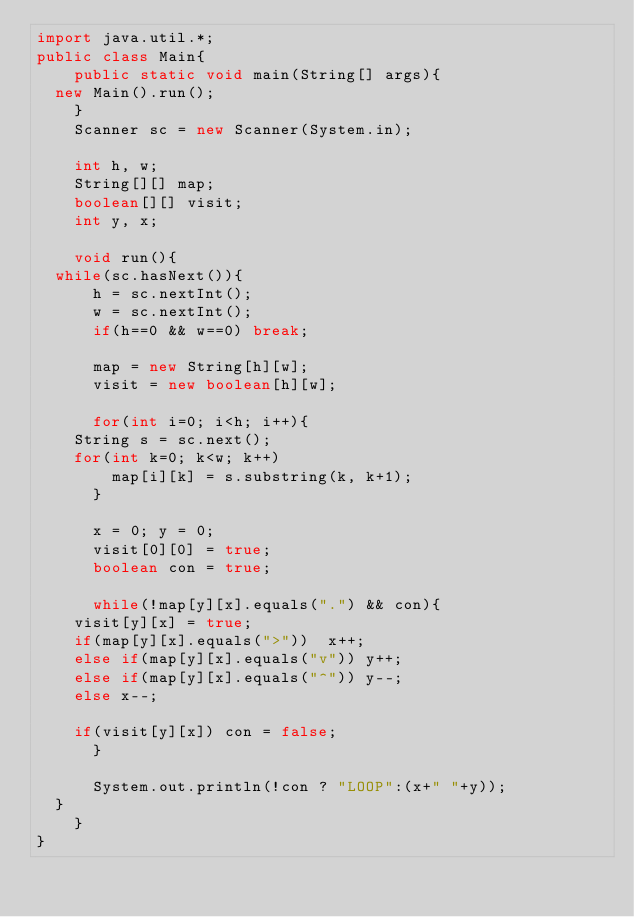Convert code to text. <code><loc_0><loc_0><loc_500><loc_500><_Java_>import java.util.*;
public class Main{
    public static void main(String[] args){
	new Main().run();
    }
    Scanner sc = new Scanner(System.in);

    int h, w;
    String[][] map;
    boolean[][] visit;
    int y, x;

    void run(){
	while(sc.hasNext()){
	    h = sc.nextInt();
	    w = sc.nextInt();
	    if(h==0 && w==0) break;

	    map = new String[h][w];
	    visit = new boolean[h][w];

	    for(int i=0; i<h; i++){
		String s = sc.next();
		for(int k=0; k<w; k++)
		    map[i][k] = s.substring(k, k+1);
	    }

	    x = 0; y = 0;
	    visit[0][0] = true;
	    boolean con = true;

	    while(!map[y][x].equals(".") && con){
		visit[y][x] = true;
		if(map[y][x].equals(">"))  x++;
		else if(map[y][x].equals("v")) y++;
		else if(map[y][x].equals("^")) y--;
		else x--;

		if(visit[y][x]) con = false;
	    }

	    System.out.println(!con ? "LOOP":(x+" "+y));
	}
    }
}</code> 